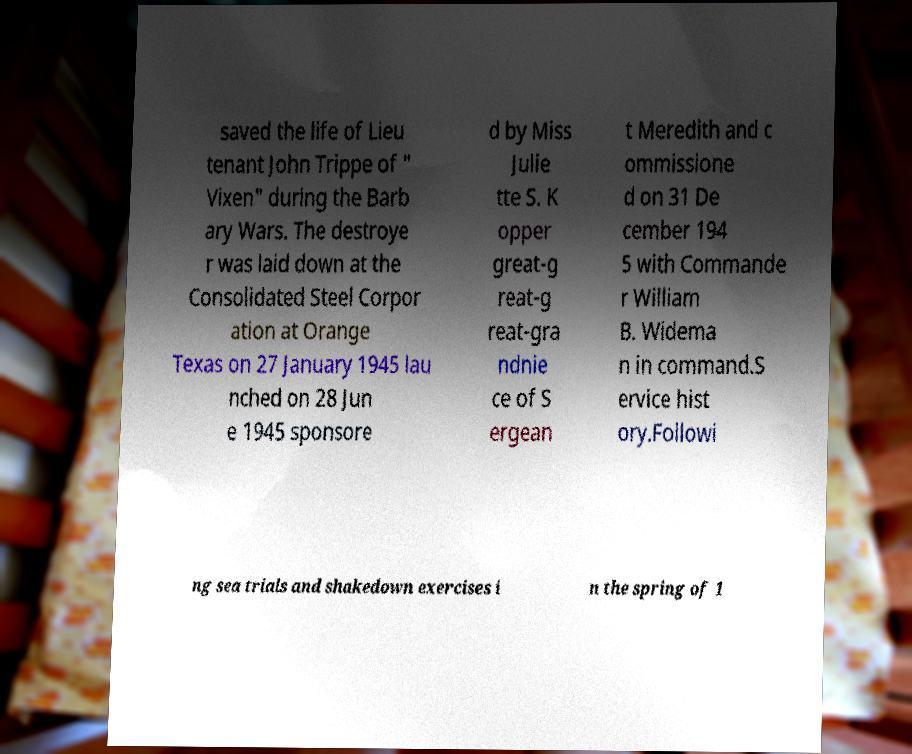What messages or text are displayed in this image? I need them in a readable, typed format. saved the life of Lieu tenant John Trippe of " Vixen" during the Barb ary Wars. The destroye r was laid down at the Consolidated Steel Corpor ation at Orange Texas on 27 January 1945 lau nched on 28 Jun e 1945 sponsore d by Miss Julie tte S. K opper great-g reat-g reat-gra ndnie ce of S ergean t Meredith and c ommissione d on 31 De cember 194 5 with Commande r William B. Widema n in command.S ervice hist ory.Followi ng sea trials and shakedown exercises i n the spring of 1 